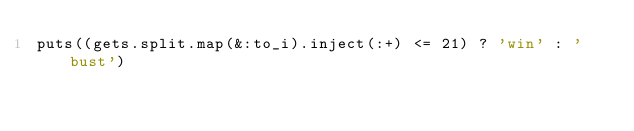Convert code to text. <code><loc_0><loc_0><loc_500><loc_500><_Ruby_>puts((gets.split.map(&:to_i).inject(:+) <= 21) ? 'win' : 'bust')</code> 